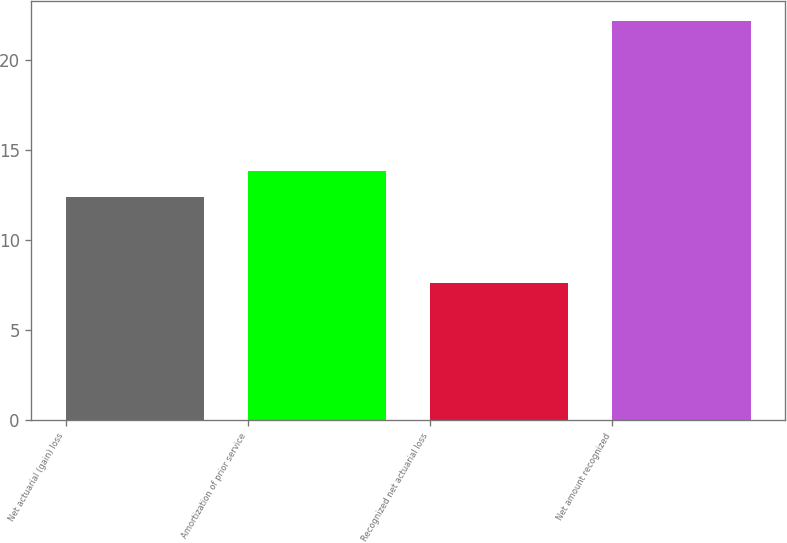Convert chart. <chart><loc_0><loc_0><loc_500><loc_500><bar_chart><fcel>Net actuarial (gain) loss<fcel>Amortization of prior service<fcel>Recognized net actuarial loss<fcel>Net amount recognized<nl><fcel>12.4<fcel>13.86<fcel>7.6<fcel>22.2<nl></chart> 